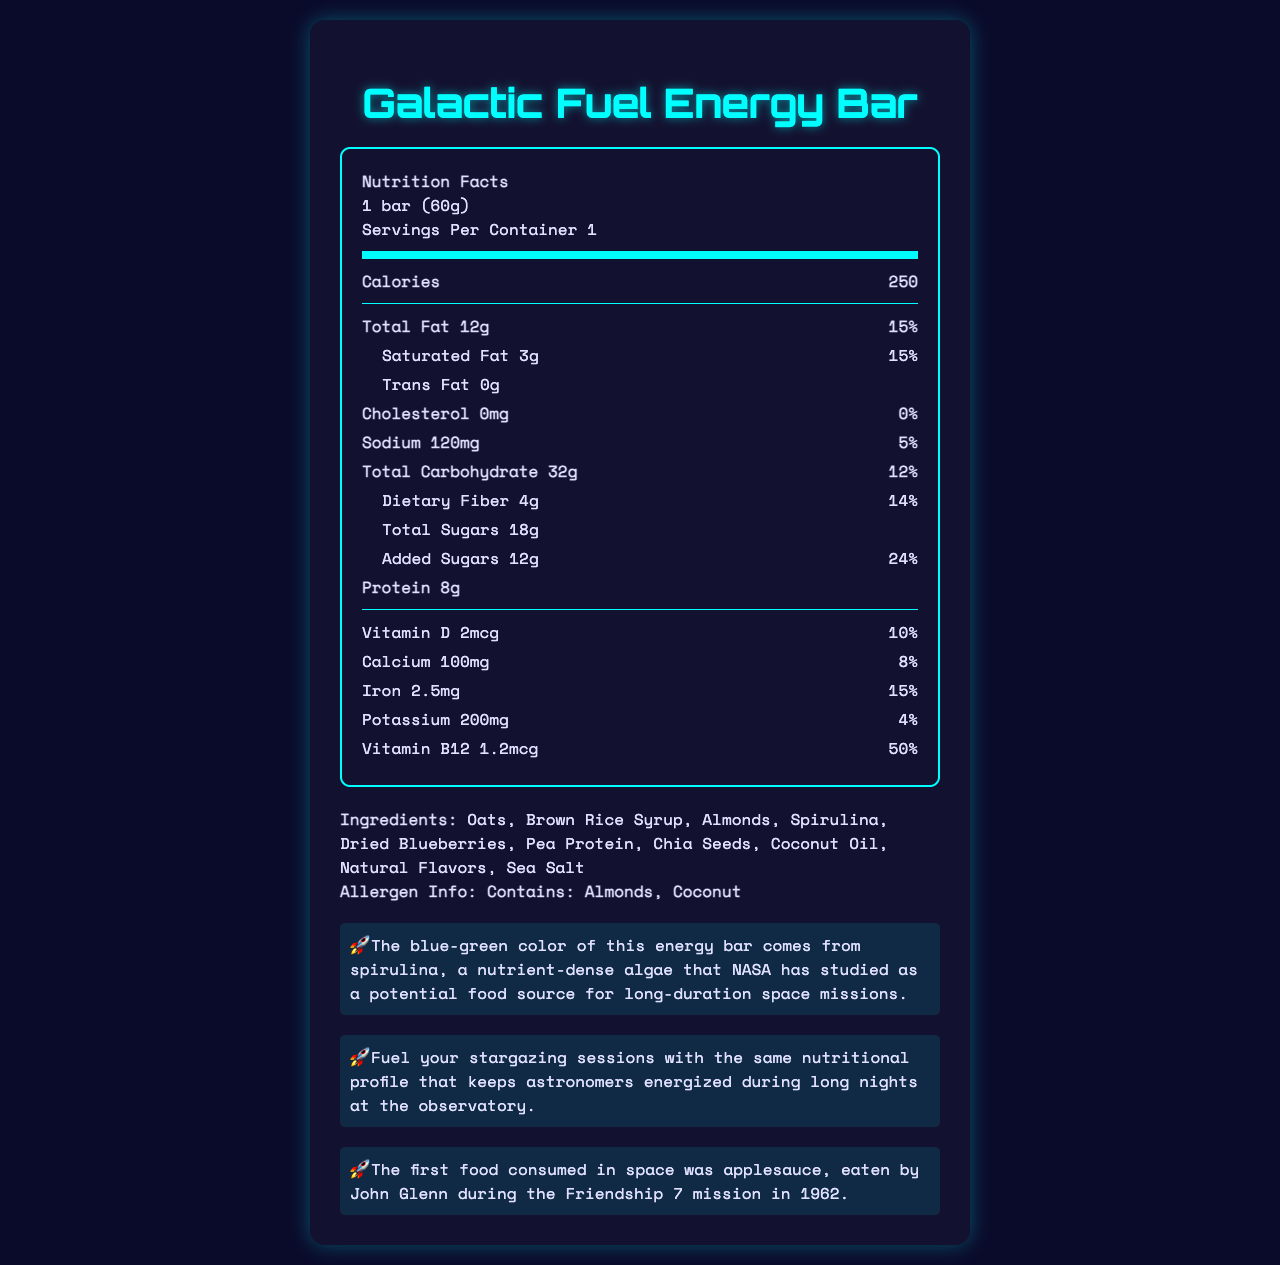what is the serving size? The serving size is stated at the top of the nutrition label as "1 bar (60g)".
Answer: 1 bar (60g) how many calories are in one serving? The calories per serving are listed as 250.
Answer: 250 how many grams of total fat does the bar contain? Under Total Fat, it states the amount as "12g" on the nutrition label.
Answer: 12g what is the daily value percentage for saturated fat? The daily value percentage for saturated fat is shown as "15%" on the label.
Answer: 15% does the bar contain any trans fat? The document lists Trans Fat as "0g", indicating that there is no trans fat.
Answer: No what is listed as the first ingredient? The first ingredient listed is Oats.
Answer: Oats how much protein does one bar provide? The amount of protein per bar is listed as 8g.
Answer: 8g which vitamin has the highest daily value percentage in the bar? A. Vitamin D B. Calcium C. Iron D. Vitamin B12 Vitamin B12 has the highest daily value percentage at 50%.
Answer: D how much sodium is in the bar? A. 50mg B. 100mg C. 120mg D. 150mg The sodium content is listed as 120mg.
Answer: C does the bar contain coconut? The allergen information states that the bar contains coconut.
Answer: Yes describe the purpose of the document in one sentence. This summary captures the main purpose of the document, which is to deliver specific nutritional and additional informative content.
Answer: The document provides the nutrition facts and additional details for the Galactic Fuel Energy Bar, a space-themed energy bar with cosmic ingredients. what is the cosmic fun fact mentioned in the document? The cosmic fun fact is stated near the end of the document under the heading "Cosmic Fun Fact."
Answer: The blue-green color of this energy bar comes from spirulina, a nutrient-dense algae that NASA has studied as a potential food source for long-duration space missions. what historical tidbit about space is included in the document? The historical space tidbit is provided under the "Space History Tidbit" section.
Answer: The first food consumed in space was applesauce, eaten by John Glenn during the Friendship 7 mission in 1962. how much calcium does the bar contain, and what percentage of daily value does this represent? The calcium content is listed as 100mg, which represents 8% of the daily value.
Answer: 100mg, 8% what are the benefits of having spirulina in the energy bar? The document only states that spirulina is a nutrient-dense algae studied by NASA but does not elaborate on specific benefits.
Answer: Not enough information which nutrients are present in smaller amounts in the energy bar considering daily value percentages? The nutrients with the smallest daily value percentages are Vitamin D, Calcium, and Potassium as indicated by their respective percentages in the document.
Answer: Vitamin D (10%), Calcium (8%), Potassium (4%) 